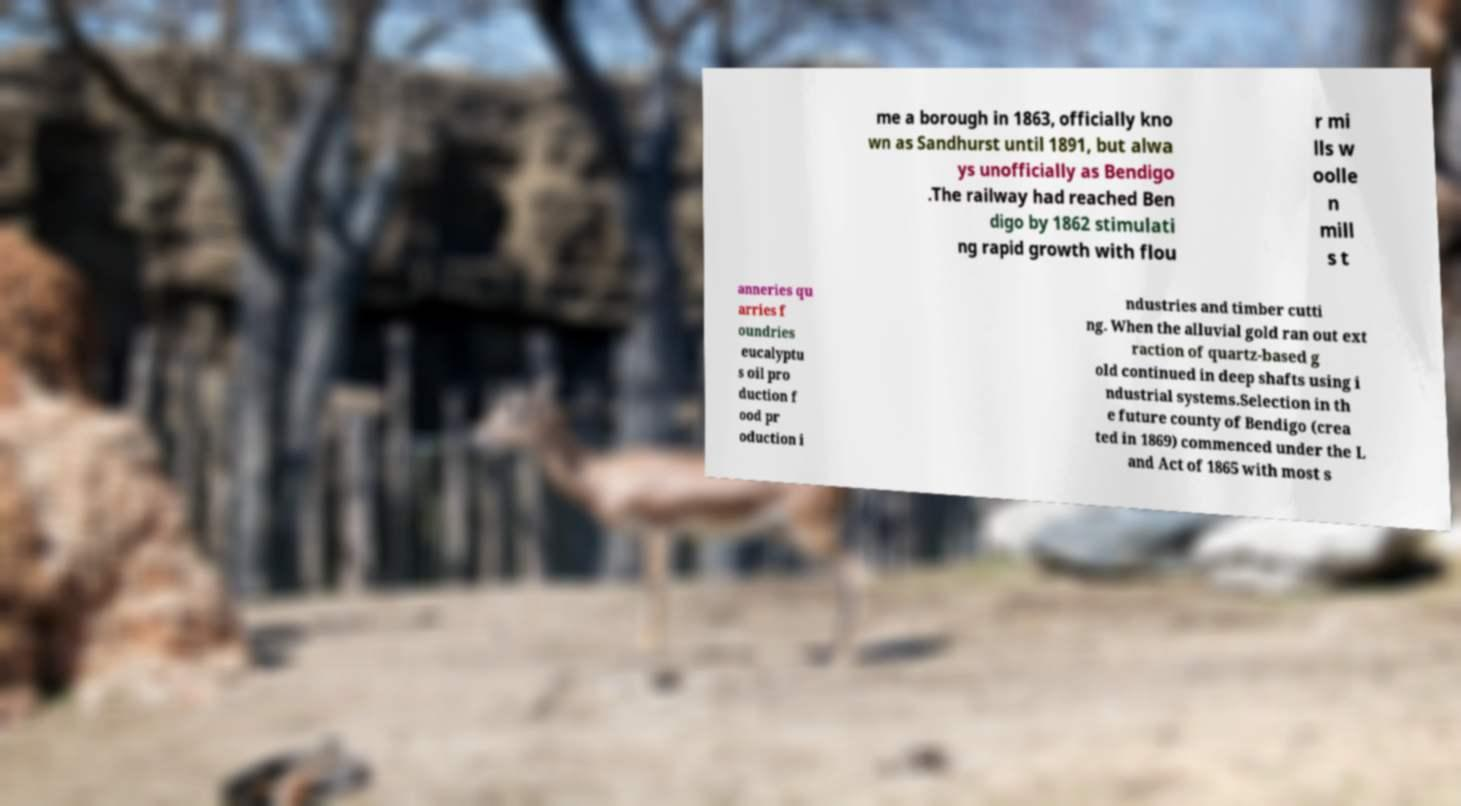Could you extract and type out the text from this image? me a borough in 1863, officially kno wn as Sandhurst until 1891, but alwa ys unofficially as Bendigo .The railway had reached Ben digo by 1862 stimulati ng rapid growth with flou r mi lls w oolle n mill s t anneries qu arries f oundries eucalyptu s oil pro duction f ood pr oduction i ndustries and timber cutti ng. When the alluvial gold ran out ext raction of quartz-based g old continued in deep shafts using i ndustrial systems.Selection in th e future county of Bendigo (crea ted in 1869) commenced under the L and Act of 1865 with most s 